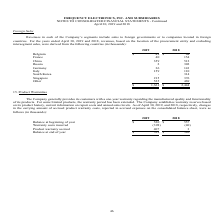From Frequency Electronics's financial document, What is the revenue from Belgium in 2019 and 2018 respectively? The document shows two values: $49 and $64 (in thousands). From the document: "ing countries (in thousands): 2019 2018 Belgium $ 49 $ 64 ountries (in thousands): 2019 2018 Belgium $ 49 $ 64..." Also, What is the revenue from France in 2019 and 2018 respectively? The document shows two values: 40 and 154 (in thousands). From the document: "France 40 154 China 359 512 Russia 2 302 Germany 36 143 Italy 159 110 South Korea - 314 Singapore 215 376 Other 5 France 40 154 China 359 512 Russia 2..." Also, What does the table show? For the years ended April 30, 2019 and 2018, revenues, based on the location of the procurement entity and excluding intersegment sales. The document states: "nts or to companies located in foreign countries. For the years ended April 30, 2019 and 2018, revenues, based on the location of the procurement enti..." Also, can you calculate: What is the average revenue from Singapore in 2018 and 2019? To answer this question, I need to perform calculations using the financial data. The calculation is: (215+ 376)/2, which equals 295.5 (in thousands). This is based on the information: "143 Italy 159 110 South Korea - 314 Singapore 215 376 Other 525 469 $ 1,361 $ 2,444 36 143 Italy 159 110 South Korea - 314 Singapore 215 376 Other 525 469 $ 1,361 $ 2,444..." The key data points involved are: 215, 376. Also, In 2019, how many countries have revenues of less than $100 thousand? Counting the relevant items in the document: Belgium ,  France ,  Russia ,  Germany, South Korea, I find 5 instances. The key data points involved are: Belgium, France, Germany. Also, can you calculate: In 2018, what is the difference in revenue between South Korea and Singapore? Based on the calculation: 376-314, the result is 62 (in thousands). This is based on the information: "143 Italy 159 110 South Korea - 314 Singapore 215 376 Other 525 469 $ 1,361 $ 2,444 2 302 Germany 36 143 Italy 159 110 South Korea - 314 Singapore 215 376 Other 525 469 $ 1,361 $ 2,444..." The key data points involved are: 314, 376. 